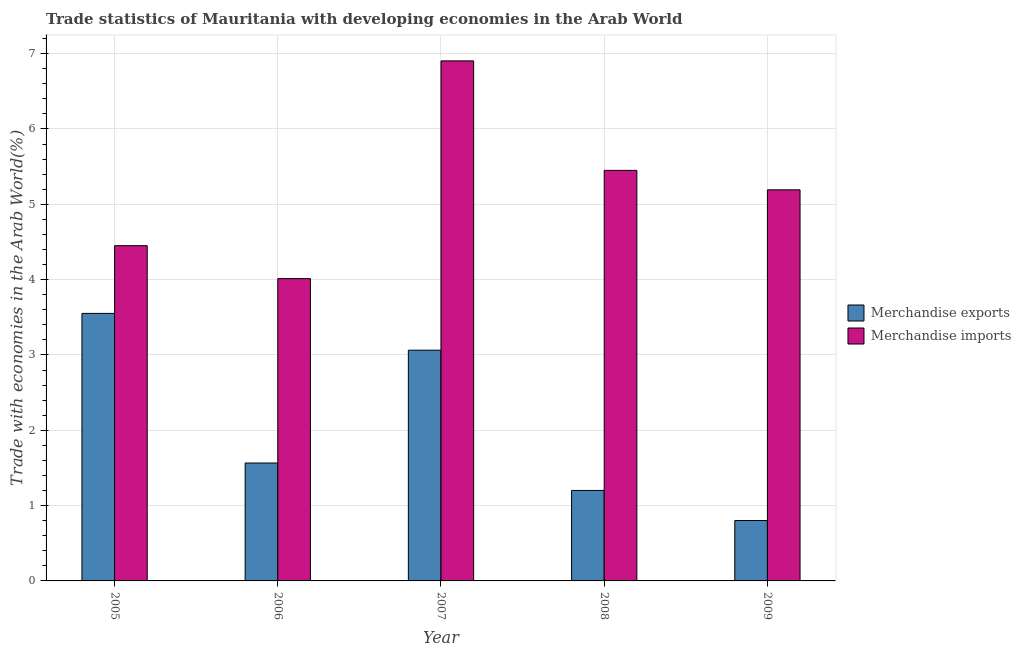How many different coloured bars are there?
Offer a terse response. 2. Are the number of bars per tick equal to the number of legend labels?
Give a very brief answer. Yes. How many bars are there on the 5th tick from the right?
Offer a terse response. 2. In how many cases, is the number of bars for a given year not equal to the number of legend labels?
Your response must be concise. 0. What is the merchandise imports in 2005?
Make the answer very short. 4.45. Across all years, what is the maximum merchandise exports?
Your answer should be compact. 3.55. Across all years, what is the minimum merchandise imports?
Provide a short and direct response. 4.01. In which year was the merchandise imports minimum?
Provide a short and direct response. 2006. What is the total merchandise imports in the graph?
Offer a terse response. 26.01. What is the difference between the merchandise imports in 2008 and that in 2009?
Your answer should be very brief. 0.26. What is the difference between the merchandise exports in 2005 and the merchandise imports in 2006?
Provide a short and direct response. 1.99. What is the average merchandise exports per year?
Give a very brief answer. 2.04. In the year 2008, what is the difference between the merchandise exports and merchandise imports?
Provide a succinct answer. 0. In how many years, is the merchandise imports greater than 1.4 %?
Your answer should be compact. 5. What is the ratio of the merchandise exports in 2005 to that in 2009?
Your response must be concise. 4.43. Is the merchandise exports in 2005 less than that in 2009?
Your answer should be very brief. No. What is the difference between the highest and the second highest merchandise imports?
Give a very brief answer. 1.45. What is the difference between the highest and the lowest merchandise imports?
Ensure brevity in your answer.  2.89. What does the 1st bar from the left in 2009 represents?
Keep it short and to the point. Merchandise exports. Are all the bars in the graph horizontal?
Provide a short and direct response. No. What is the difference between two consecutive major ticks on the Y-axis?
Offer a very short reply. 1. Are the values on the major ticks of Y-axis written in scientific E-notation?
Offer a very short reply. No. Does the graph contain any zero values?
Your response must be concise. No. Where does the legend appear in the graph?
Make the answer very short. Center right. What is the title of the graph?
Provide a succinct answer. Trade statistics of Mauritania with developing economies in the Arab World. Does "Nitrous oxide" appear as one of the legend labels in the graph?
Offer a very short reply. No. What is the label or title of the X-axis?
Provide a short and direct response. Year. What is the label or title of the Y-axis?
Make the answer very short. Trade with economies in the Arab World(%). What is the Trade with economies in the Arab World(%) of Merchandise exports in 2005?
Offer a very short reply. 3.55. What is the Trade with economies in the Arab World(%) in Merchandise imports in 2005?
Your response must be concise. 4.45. What is the Trade with economies in the Arab World(%) in Merchandise exports in 2006?
Give a very brief answer. 1.57. What is the Trade with economies in the Arab World(%) of Merchandise imports in 2006?
Ensure brevity in your answer.  4.01. What is the Trade with economies in the Arab World(%) in Merchandise exports in 2007?
Give a very brief answer. 3.06. What is the Trade with economies in the Arab World(%) of Merchandise imports in 2007?
Ensure brevity in your answer.  6.9. What is the Trade with economies in the Arab World(%) of Merchandise exports in 2008?
Make the answer very short. 1.2. What is the Trade with economies in the Arab World(%) in Merchandise imports in 2008?
Keep it short and to the point. 5.45. What is the Trade with economies in the Arab World(%) in Merchandise exports in 2009?
Your response must be concise. 0.8. What is the Trade with economies in the Arab World(%) of Merchandise imports in 2009?
Provide a succinct answer. 5.19. Across all years, what is the maximum Trade with economies in the Arab World(%) in Merchandise exports?
Your answer should be very brief. 3.55. Across all years, what is the maximum Trade with economies in the Arab World(%) in Merchandise imports?
Offer a very short reply. 6.9. Across all years, what is the minimum Trade with economies in the Arab World(%) in Merchandise exports?
Offer a very short reply. 0.8. Across all years, what is the minimum Trade with economies in the Arab World(%) in Merchandise imports?
Make the answer very short. 4.01. What is the total Trade with economies in the Arab World(%) of Merchandise exports in the graph?
Your response must be concise. 10.18. What is the total Trade with economies in the Arab World(%) of Merchandise imports in the graph?
Ensure brevity in your answer.  26.01. What is the difference between the Trade with economies in the Arab World(%) in Merchandise exports in 2005 and that in 2006?
Offer a terse response. 1.99. What is the difference between the Trade with economies in the Arab World(%) in Merchandise imports in 2005 and that in 2006?
Ensure brevity in your answer.  0.44. What is the difference between the Trade with economies in the Arab World(%) of Merchandise exports in 2005 and that in 2007?
Keep it short and to the point. 0.49. What is the difference between the Trade with economies in the Arab World(%) in Merchandise imports in 2005 and that in 2007?
Offer a very short reply. -2.45. What is the difference between the Trade with economies in the Arab World(%) in Merchandise exports in 2005 and that in 2008?
Your answer should be very brief. 2.35. What is the difference between the Trade with economies in the Arab World(%) of Merchandise imports in 2005 and that in 2008?
Make the answer very short. -1. What is the difference between the Trade with economies in the Arab World(%) in Merchandise exports in 2005 and that in 2009?
Your answer should be very brief. 2.75. What is the difference between the Trade with economies in the Arab World(%) of Merchandise imports in 2005 and that in 2009?
Ensure brevity in your answer.  -0.74. What is the difference between the Trade with economies in the Arab World(%) of Merchandise exports in 2006 and that in 2007?
Offer a very short reply. -1.5. What is the difference between the Trade with economies in the Arab World(%) of Merchandise imports in 2006 and that in 2007?
Provide a short and direct response. -2.89. What is the difference between the Trade with economies in the Arab World(%) of Merchandise exports in 2006 and that in 2008?
Provide a succinct answer. 0.36. What is the difference between the Trade with economies in the Arab World(%) of Merchandise imports in 2006 and that in 2008?
Your answer should be very brief. -1.44. What is the difference between the Trade with economies in the Arab World(%) of Merchandise exports in 2006 and that in 2009?
Provide a short and direct response. 0.76. What is the difference between the Trade with economies in the Arab World(%) of Merchandise imports in 2006 and that in 2009?
Keep it short and to the point. -1.18. What is the difference between the Trade with economies in the Arab World(%) of Merchandise exports in 2007 and that in 2008?
Your answer should be very brief. 1.86. What is the difference between the Trade with economies in the Arab World(%) of Merchandise imports in 2007 and that in 2008?
Offer a terse response. 1.45. What is the difference between the Trade with economies in the Arab World(%) of Merchandise exports in 2007 and that in 2009?
Provide a short and direct response. 2.26. What is the difference between the Trade with economies in the Arab World(%) in Merchandise imports in 2007 and that in 2009?
Your answer should be compact. 1.71. What is the difference between the Trade with economies in the Arab World(%) of Merchandise exports in 2008 and that in 2009?
Keep it short and to the point. 0.4. What is the difference between the Trade with economies in the Arab World(%) of Merchandise imports in 2008 and that in 2009?
Your response must be concise. 0.26. What is the difference between the Trade with economies in the Arab World(%) of Merchandise exports in 2005 and the Trade with economies in the Arab World(%) of Merchandise imports in 2006?
Your answer should be compact. -0.46. What is the difference between the Trade with economies in the Arab World(%) of Merchandise exports in 2005 and the Trade with economies in the Arab World(%) of Merchandise imports in 2007?
Give a very brief answer. -3.35. What is the difference between the Trade with economies in the Arab World(%) of Merchandise exports in 2005 and the Trade with economies in the Arab World(%) of Merchandise imports in 2008?
Ensure brevity in your answer.  -1.9. What is the difference between the Trade with economies in the Arab World(%) of Merchandise exports in 2005 and the Trade with economies in the Arab World(%) of Merchandise imports in 2009?
Provide a short and direct response. -1.64. What is the difference between the Trade with economies in the Arab World(%) of Merchandise exports in 2006 and the Trade with economies in the Arab World(%) of Merchandise imports in 2007?
Keep it short and to the point. -5.34. What is the difference between the Trade with economies in the Arab World(%) of Merchandise exports in 2006 and the Trade with economies in the Arab World(%) of Merchandise imports in 2008?
Provide a short and direct response. -3.88. What is the difference between the Trade with economies in the Arab World(%) of Merchandise exports in 2006 and the Trade with economies in the Arab World(%) of Merchandise imports in 2009?
Your answer should be very brief. -3.63. What is the difference between the Trade with economies in the Arab World(%) of Merchandise exports in 2007 and the Trade with economies in the Arab World(%) of Merchandise imports in 2008?
Your answer should be very brief. -2.39. What is the difference between the Trade with economies in the Arab World(%) of Merchandise exports in 2007 and the Trade with economies in the Arab World(%) of Merchandise imports in 2009?
Make the answer very short. -2.13. What is the difference between the Trade with economies in the Arab World(%) of Merchandise exports in 2008 and the Trade with economies in the Arab World(%) of Merchandise imports in 2009?
Provide a succinct answer. -3.99. What is the average Trade with economies in the Arab World(%) in Merchandise exports per year?
Offer a terse response. 2.04. What is the average Trade with economies in the Arab World(%) in Merchandise imports per year?
Provide a succinct answer. 5.2. In the year 2005, what is the difference between the Trade with economies in the Arab World(%) of Merchandise exports and Trade with economies in the Arab World(%) of Merchandise imports?
Make the answer very short. -0.9. In the year 2006, what is the difference between the Trade with economies in the Arab World(%) of Merchandise exports and Trade with economies in the Arab World(%) of Merchandise imports?
Your response must be concise. -2.45. In the year 2007, what is the difference between the Trade with economies in the Arab World(%) of Merchandise exports and Trade with economies in the Arab World(%) of Merchandise imports?
Ensure brevity in your answer.  -3.84. In the year 2008, what is the difference between the Trade with economies in the Arab World(%) in Merchandise exports and Trade with economies in the Arab World(%) in Merchandise imports?
Your answer should be compact. -4.25. In the year 2009, what is the difference between the Trade with economies in the Arab World(%) of Merchandise exports and Trade with economies in the Arab World(%) of Merchandise imports?
Offer a terse response. -4.39. What is the ratio of the Trade with economies in the Arab World(%) in Merchandise exports in 2005 to that in 2006?
Ensure brevity in your answer.  2.27. What is the ratio of the Trade with economies in the Arab World(%) of Merchandise imports in 2005 to that in 2006?
Provide a succinct answer. 1.11. What is the ratio of the Trade with economies in the Arab World(%) of Merchandise exports in 2005 to that in 2007?
Give a very brief answer. 1.16. What is the ratio of the Trade with economies in the Arab World(%) of Merchandise imports in 2005 to that in 2007?
Offer a terse response. 0.64. What is the ratio of the Trade with economies in the Arab World(%) of Merchandise exports in 2005 to that in 2008?
Your answer should be very brief. 2.96. What is the ratio of the Trade with economies in the Arab World(%) in Merchandise imports in 2005 to that in 2008?
Make the answer very short. 0.82. What is the ratio of the Trade with economies in the Arab World(%) of Merchandise exports in 2005 to that in 2009?
Make the answer very short. 4.43. What is the ratio of the Trade with economies in the Arab World(%) in Merchandise imports in 2005 to that in 2009?
Your response must be concise. 0.86. What is the ratio of the Trade with economies in the Arab World(%) of Merchandise exports in 2006 to that in 2007?
Your response must be concise. 0.51. What is the ratio of the Trade with economies in the Arab World(%) in Merchandise imports in 2006 to that in 2007?
Provide a succinct answer. 0.58. What is the ratio of the Trade with economies in the Arab World(%) of Merchandise exports in 2006 to that in 2008?
Offer a very short reply. 1.3. What is the ratio of the Trade with economies in the Arab World(%) in Merchandise imports in 2006 to that in 2008?
Offer a very short reply. 0.74. What is the ratio of the Trade with economies in the Arab World(%) in Merchandise exports in 2006 to that in 2009?
Keep it short and to the point. 1.95. What is the ratio of the Trade with economies in the Arab World(%) of Merchandise imports in 2006 to that in 2009?
Your answer should be very brief. 0.77. What is the ratio of the Trade with economies in the Arab World(%) of Merchandise exports in 2007 to that in 2008?
Provide a short and direct response. 2.55. What is the ratio of the Trade with economies in the Arab World(%) in Merchandise imports in 2007 to that in 2008?
Keep it short and to the point. 1.27. What is the ratio of the Trade with economies in the Arab World(%) in Merchandise exports in 2007 to that in 2009?
Give a very brief answer. 3.82. What is the ratio of the Trade with economies in the Arab World(%) in Merchandise imports in 2007 to that in 2009?
Make the answer very short. 1.33. What is the ratio of the Trade with economies in the Arab World(%) in Merchandise exports in 2008 to that in 2009?
Keep it short and to the point. 1.5. What is the ratio of the Trade with economies in the Arab World(%) of Merchandise imports in 2008 to that in 2009?
Ensure brevity in your answer.  1.05. What is the difference between the highest and the second highest Trade with economies in the Arab World(%) of Merchandise exports?
Provide a succinct answer. 0.49. What is the difference between the highest and the second highest Trade with economies in the Arab World(%) in Merchandise imports?
Keep it short and to the point. 1.45. What is the difference between the highest and the lowest Trade with economies in the Arab World(%) of Merchandise exports?
Ensure brevity in your answer.  2.75. What is the difference between the highest and the lowest Trade with economies in the Arab World(%) in Merchandise imports?
Offer a very short reply. 2.89. 